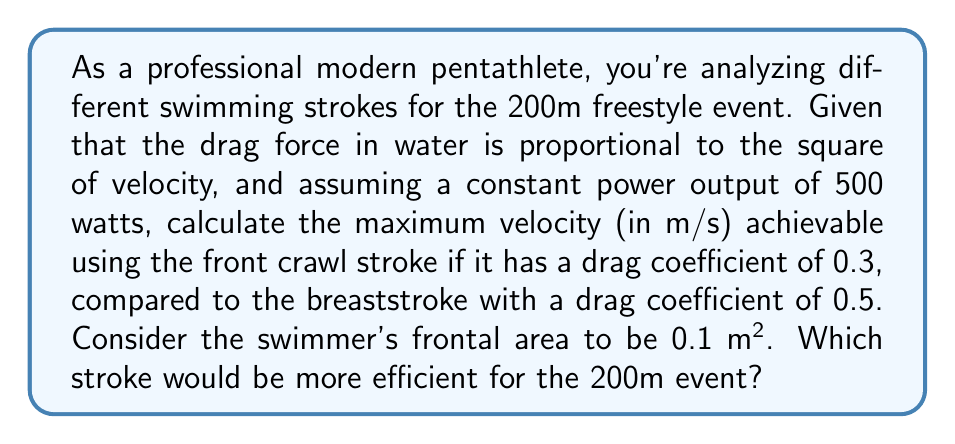Solve this math problem. Let's approach this step-by-step:

1) The drag force in water is given by the equation:

   $$F_d = \frac{1}{2} \rho C_d A v^2$$

   where $\rho$ is the density of water, $C_d$ is the drag coefficient, $A$ is the frontal area, and $v$ is the velocity.

2) Power is the product of force and velocity:

   $$P = F_d v$$

3) Substituting the drag force equation into the power equation:

   $$P = \frac{1}{2} \rho C_d A v^3$$

4) We can rearrange this to solve for velocity:

   $$v = \sqrt[3]{\frac{2P}{\rho C_d A}}$$

5) Given:
   - Power (P) = 500 W
   - Density of water ($\rho$) ≈ 1000 kg/m³
   - Frontal area (A) = 0.1 m²
   - Front crawl drag coefficient ($C_{d1}$) = 0.3
   - Breaststroke drag coefficient ($C_{d2}$) = 0.5

6) For front crawl:

   $$v_1 = \sqrt[3]{\frac{2 \cdot 500}{1000 \cdot 0.3 \cdot 0.1}} \approx 2.15 \text{ m/s}$$

7) For breaststroke:

   $$v_2 = \sqrt[3]{\frac{2 \cdot 500}{1000 \cdot 0.5 \cdot 0.1}} \approx 1.82 \text{ m/s}$$

8) The front crawl allows for a higher maximum velocity (2.15 m/s vs 1.82 m/s).

9) For a 200m event, time taken:
   - Front crawl: 200 / 2.15 ≈ 93.0 seconds
   - Breaststroke: 200 / 1.82 ≈ 109.9 seconds

Therefore, the front crawl is more efficient for the 200m event.
Answer: Front crawl; 2.15 m/s 